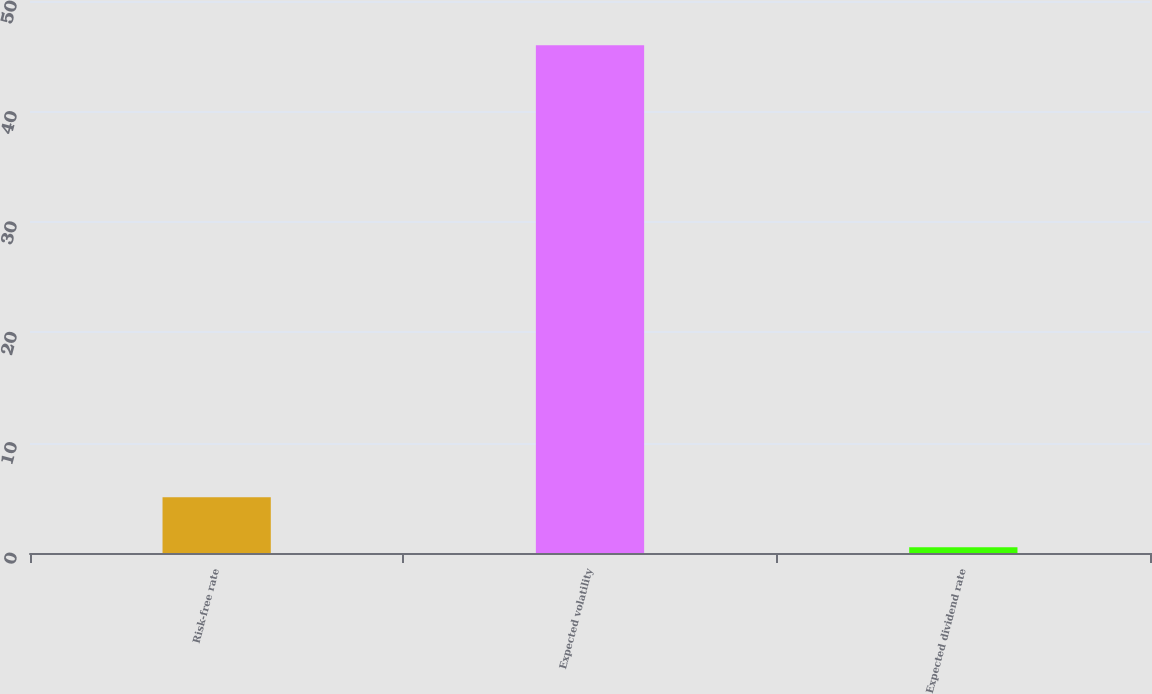Convert chart to OTSL. <chart><loc_0><loc_0><loc_500><loc_500><bar_chart><fcel>Risk-free rate<fcel>Expected volatility<fcel>Expected dividend rate<nl><fcel>5.06<fcel>46<fcel>0.51<nl></chart> 